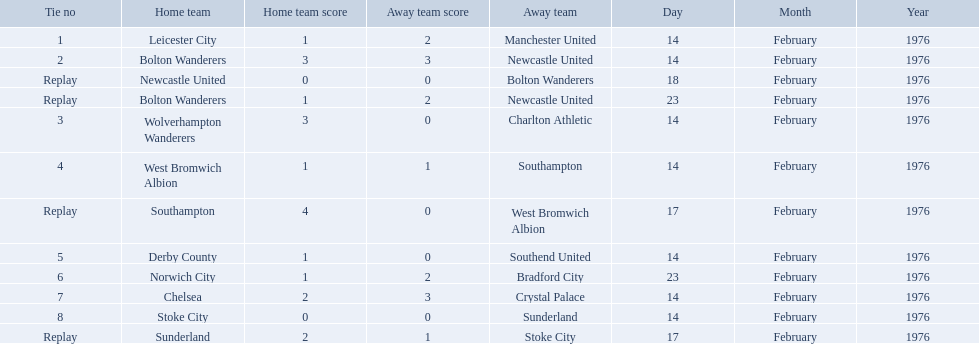What are all of the scores of the 1975-76 fa cup? 1–2, 3–3, 0–0, 1–2, 3–0, 1–1, 4–0, 1–0, 1–2, 2–3, 0–0, 2–1. What are the scores for manchester united or wolverhampton wanderers? 1–2, 3–0. Which has the highest score? 3–0. Who was this score for? Wolverhampton Wanderers. What teams are featured in the game at the top of the table? Leicester City, Manchester United. Which of these two is the home team? Leicester City. What is the game at the top of the table? 1. Could you parse the entire table as a dict? {'header': ['Tie no', 'Home team', 'Home team score', 'Away team score', 'Away team', 'Day', 'Month', 'Year'], 'rows': [['1', 'Leicester City', '1', '2', 'Manchester United', '14', 'February', '1976'], ['2', 'Bolton Wanderers', '3', '3', 'Newcastle United', '14', 'February', '1976'], ['Replay', 'Newcastle United', '0', '0', 'Bolton Wanderers', '18', 'February', '1976'], ['Replay', 'Bolton Wanderers', '1', '2', 'Newcastle United', '23', 'February', '1976'], ['3', 'Wolverhampton Wanderers', '3', '0', 'Charlton Athletic', '14', 'February', '1976'], ['4', 'West Bromwich Albion', '1', '1', 'Southampton', '14', 'February', '1976'], ['Replay', 'Southampton', '4', '0', 'West Bromwich Albion', '17', 'February', '1976'], ['5', 'Derby County', '1', '0', 'Southend United', '14', 'February', '1976'], ['6', 'Norwich City', '1', '2', 'Bradford City', '23', 'February', '1976'], ['7', 'Chelsea', '2', '3', 'Crystal Palace', '14', 'February', '1976'], ['8', 'Stoke City', '0', '0', 'Sunderland', '14', 'February', '1976'], ['Replay', 'Sunderland', '2', '1', 'Stoke City', '17', 'February', '1976']]} Who is the home team for this game? Leicester City. 